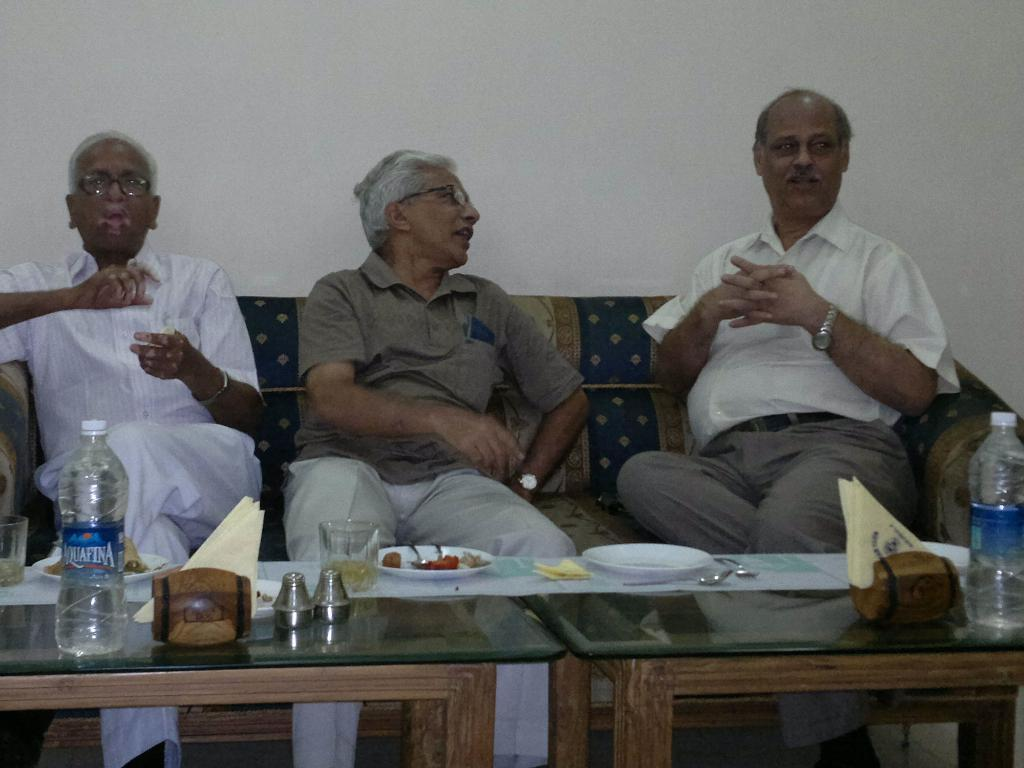How many people are sitting on the couch in the image? There are three persons sitting on the couch in the image. What is located in front of the couch? The couch is in front of a table. What items can be seen on the table in the image? There are water bottles, tissues, a glass, and plates on the table in the image. What type of education does the farmer in the image have? There is no farmer present in the image, so it is not possible to determine their level of education. 